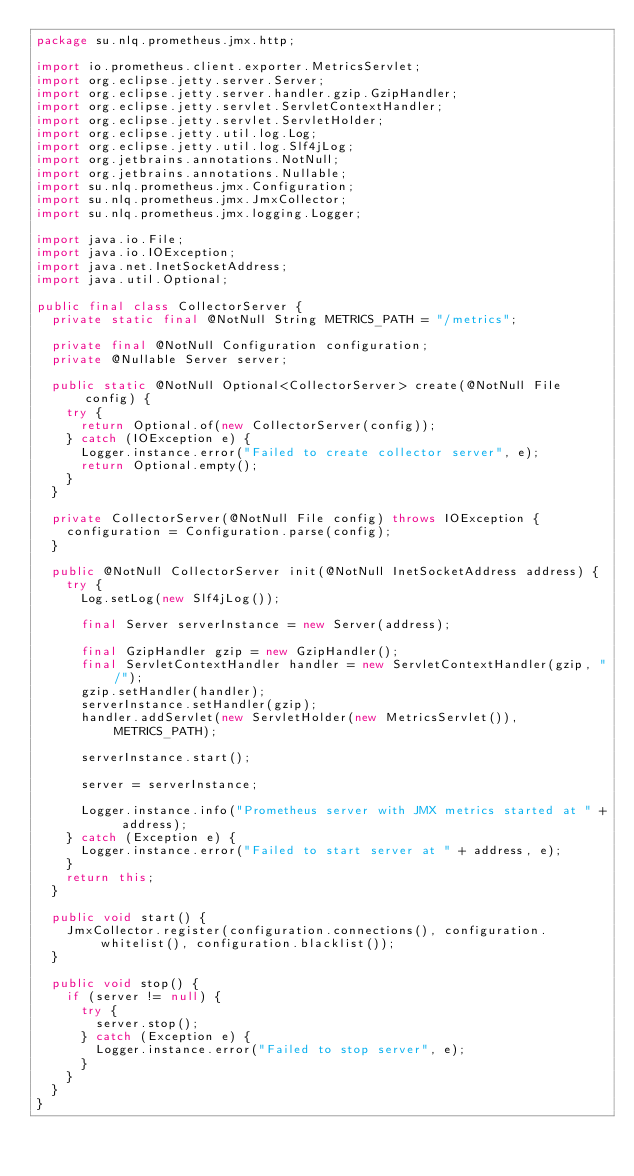Convert code to text. <code><loc_0><loc_0><loc_500><loc_500><_Java_>package su.nlq.prometheus.jmx.http;

import io.prometheus.client.exporter.MetricsServlet;
import org.eclipse.jetty.server.Server;
import org.eclipse.jetty.server.handler.gzip.GzipHandler;
import org.eclipse.jetty.servlet.ServletContextHandler;
import org.eclipse.jetty.servlet.ServletHolder;
import org.eclipse.jetty.util.log.Log;
import org.eclipse.jetty.util.log.Slf4jLog;
import org.jetbrains.annotations.NotNull;
import org.jetbrains.annotations.Nullable;
import su.nlq.prometheus.jmx.Configuration;
import su.nlq.prometheus.jmx.JmxCollector;
import su.nlq.prometheus.jmx.logging.Logger;

import java.io.File;
import java.io.IOException;
import java.net.InetSocketAddress;
import java.util.Optional;

public final class CollectorServer {
  private static final @NotNull String METRICS_PATH = "/metrics";

  private final @NotNull Configuration configuration;
  private @Nullable Server server;

  public static @NotNull Optional<CollectorServer> create(@NotNull File config) {
    try {
      return Optional.of(new CollectorServer(config));
    } catch (IOException e) {
      Logger.instance.error("Failed to create collector server", e);
      return Optional.empty();
    }
  }

  private CollectorServer(@NotNull File config) throws IOException {
    configuration = Configuration.parse(config);
  }

  public @NotNull CollectorServer init(@NotNull InetSocketAddress address) {
    try {
      Log.setLog(new Slf4jLog());

      final Server serverInstance = new Server(address);

      final GzipHandler gzip = new GzipHandler();
      final ServletContextHandler handler = new ServletContextHandler(gzip, "/");
      gzip.setHandler(handler);
      serverInstance.setHandler(gzip);
      handler.addServlet(new ServletHolder(new MetricsServlet()), METRICS_PATH);

      serverInstance.start();

      server = serverInstance;

      Logger.instance.info("Prometheus server with JMX metrics started at " + address);
    } catch (Exception e) {
      Logger.instance.error("Failed to start server at " + address, e);
    }
    return this;
  }

  public void start() {
    JmxCollector.register(configuration.connections(), configuration.whitelist(), configuration.blacklist());
  }

  public void stop() {
    if (server != null) {
      try {
        server.stop();
      } catch (Exception e) {
        Logger.instance.error("Failed to stop server", e);
      }
    }
  }
}
</code> 